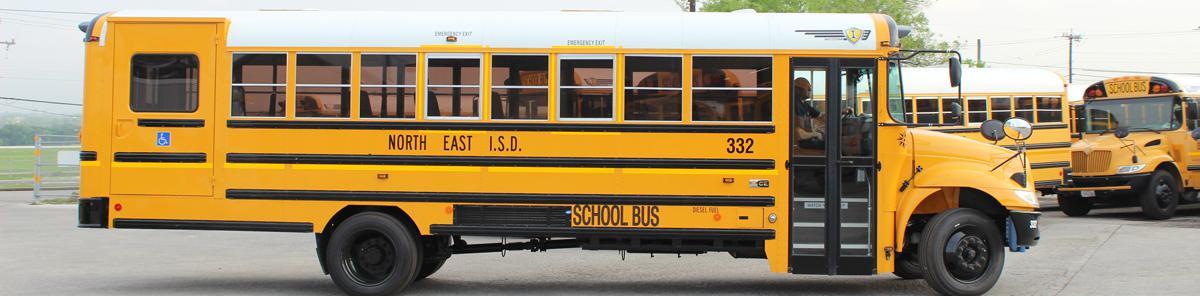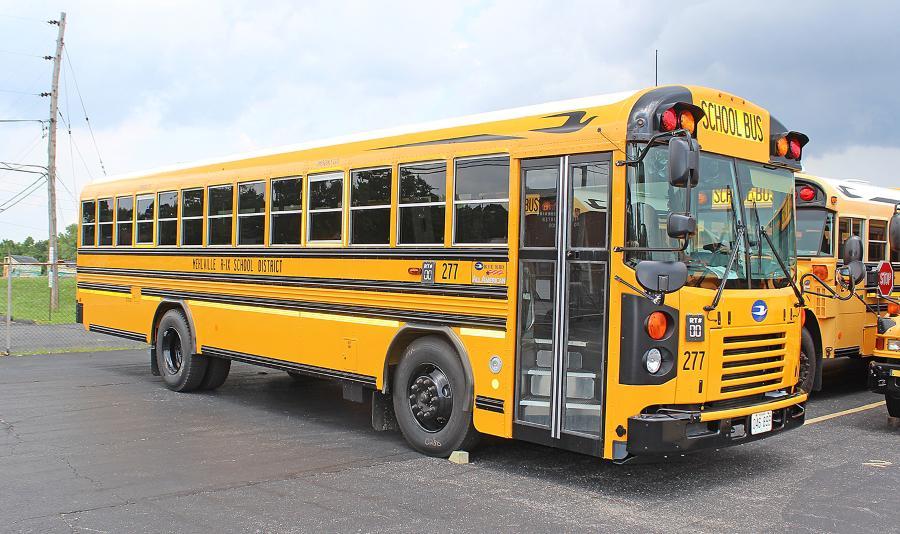The first image is the image on the left, the second image is the image on the right. Assess this claim about the two images: "In at least one image there is an emergency exit in the back of the bus face forward with the front of the bus not visible.". Correct or not? Answer yes or no. No. The first image is the image on the left, the second image is the image on the right. Assess this claim about the two images: "The right image shows a flat-fronted bus angled facing forward.". Correct or not? Answer yes or no. Yes. 